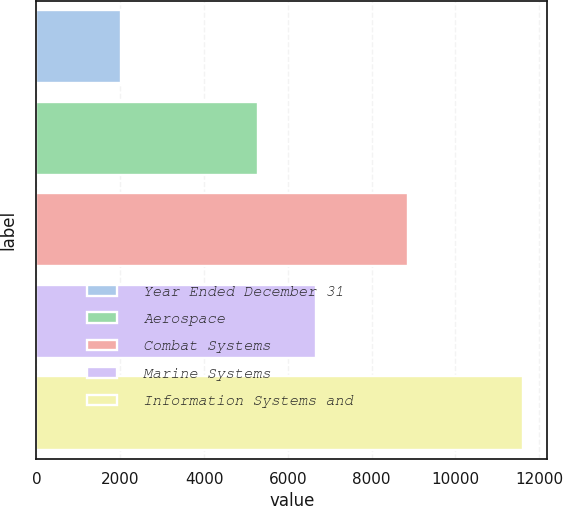Convert chart to OTSL. <chart><loc_0><loc_0><loc_500><loc_500><bar_chart><fcel>Year Ended December 31<fcel>Aerospace<fcel>Combat Systems<fcel>Marine Systems<fcel>Information Systems and<nl><fcel>2010<fcel>5299<fcel>8878<fcel>6677<fcel>11612<nl></chart> 